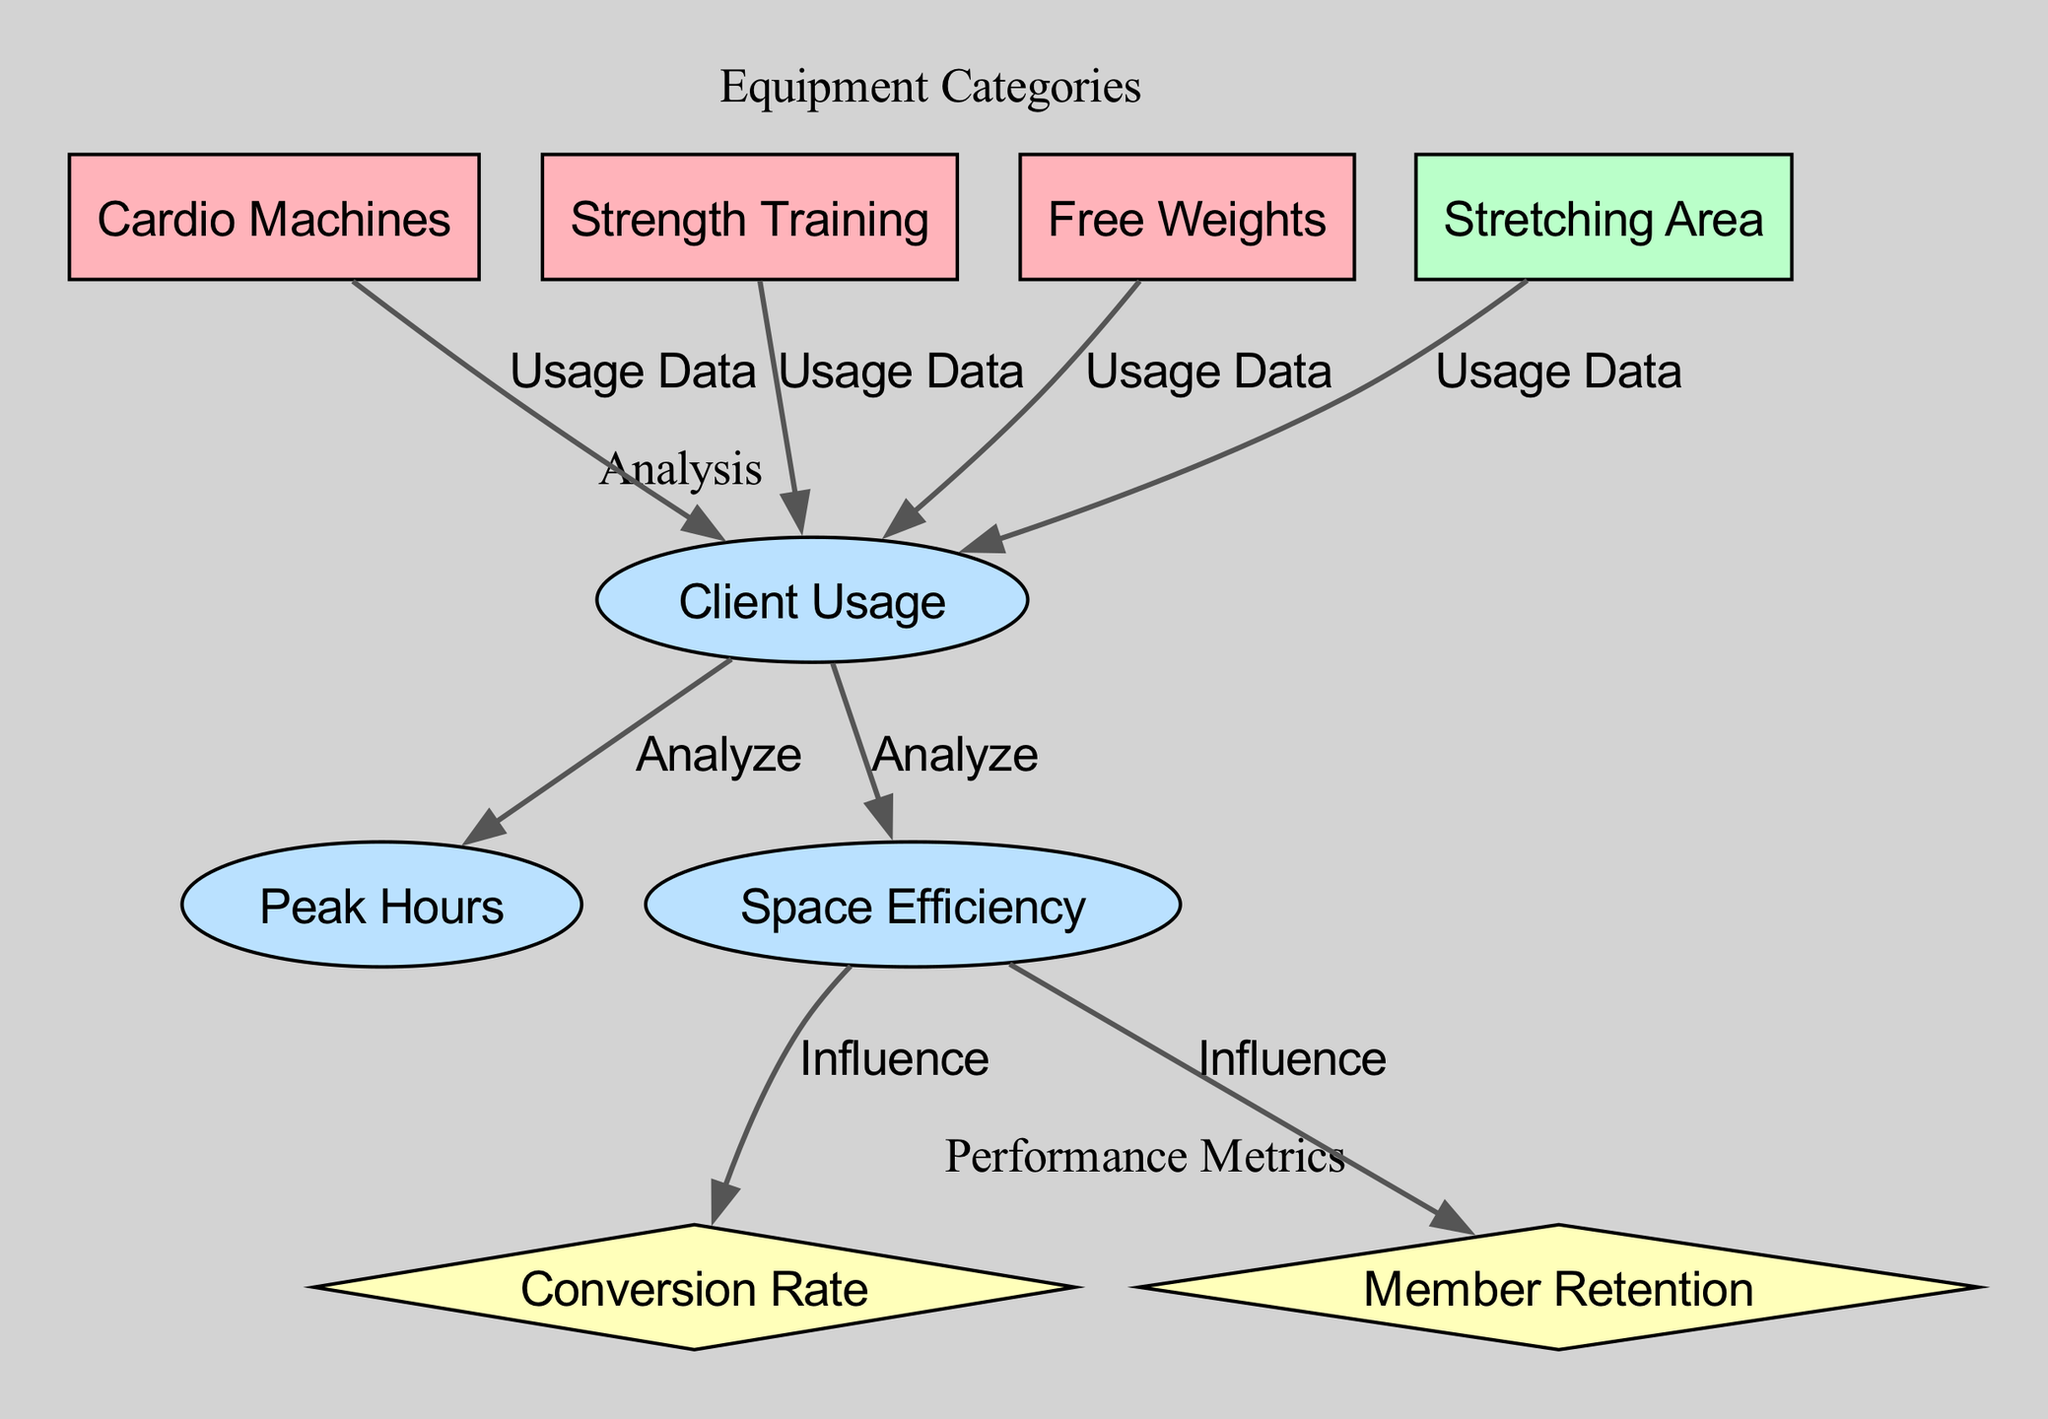What's the total number of nodes in the diagram? The diagram features a total of 8 nodes, including equipment categories, space categories, analyses, and performance metrics.
Answer: 8 Which equipment category influences client usage? All equipment categories (Cardio Machines, Strength Training, Free Weights, Stretching Area) have edges labeled "Usage Data" that point to Client Usage, indicating their influence.
Answer: Cardio Machines, Strength Training, Free Weights, Stretching Area What does space efficiency influence? Space Efficiency influences both the Conversion Rate and Member Retention as shown by the directed edges connecting these nodes.
Answer: Conversion Rate, Member Retention How many analysis nodes are in the diagram? There are three analysis nodes: Client Usage, Peak Hours, and Space Efficiency.
Answer: 3 Which node does Client Usage analyze? Client Usage is analyzed for both Peak Hours and Space Efficiency, which are directly connected with "Analyze" edges.
Answer: Peak Hours, Space Efficiency What are the colors used for performance metric nodes? The performance metric nodes are colored yellow, or #FFFFBA, indicating their specific category.
Answer: Yellow Which equipment category has no direct influence on performance metrics? Free Weights does not have a direct influence on Conversion Rate or Member Retention; it only connects to Client Usage.
Answer: Free Weights How does space efficiency relate to the equipment categories? Space Efficiency is indirectly connected through Client Usage, which aggregates the usage data from all four equipment categories, linking them through space efficiency analysis.
Answer: Indirectly through Client Usage 